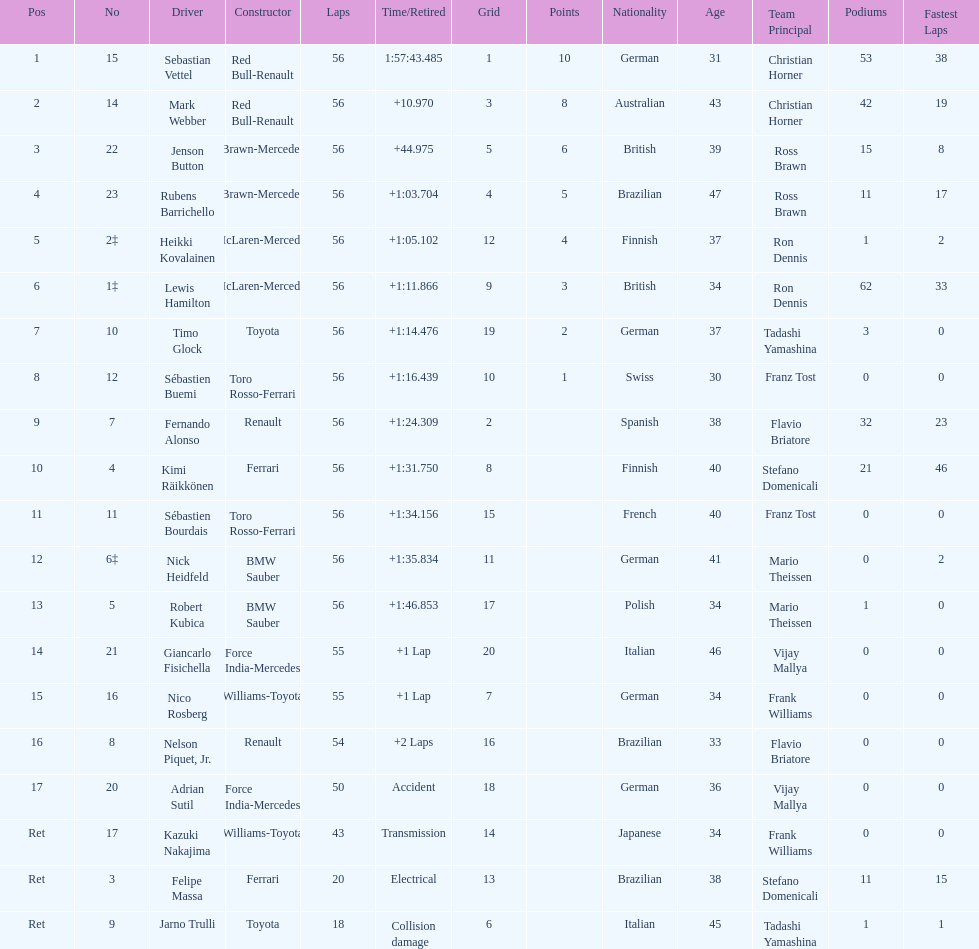How many laps in total is the race? 56. 